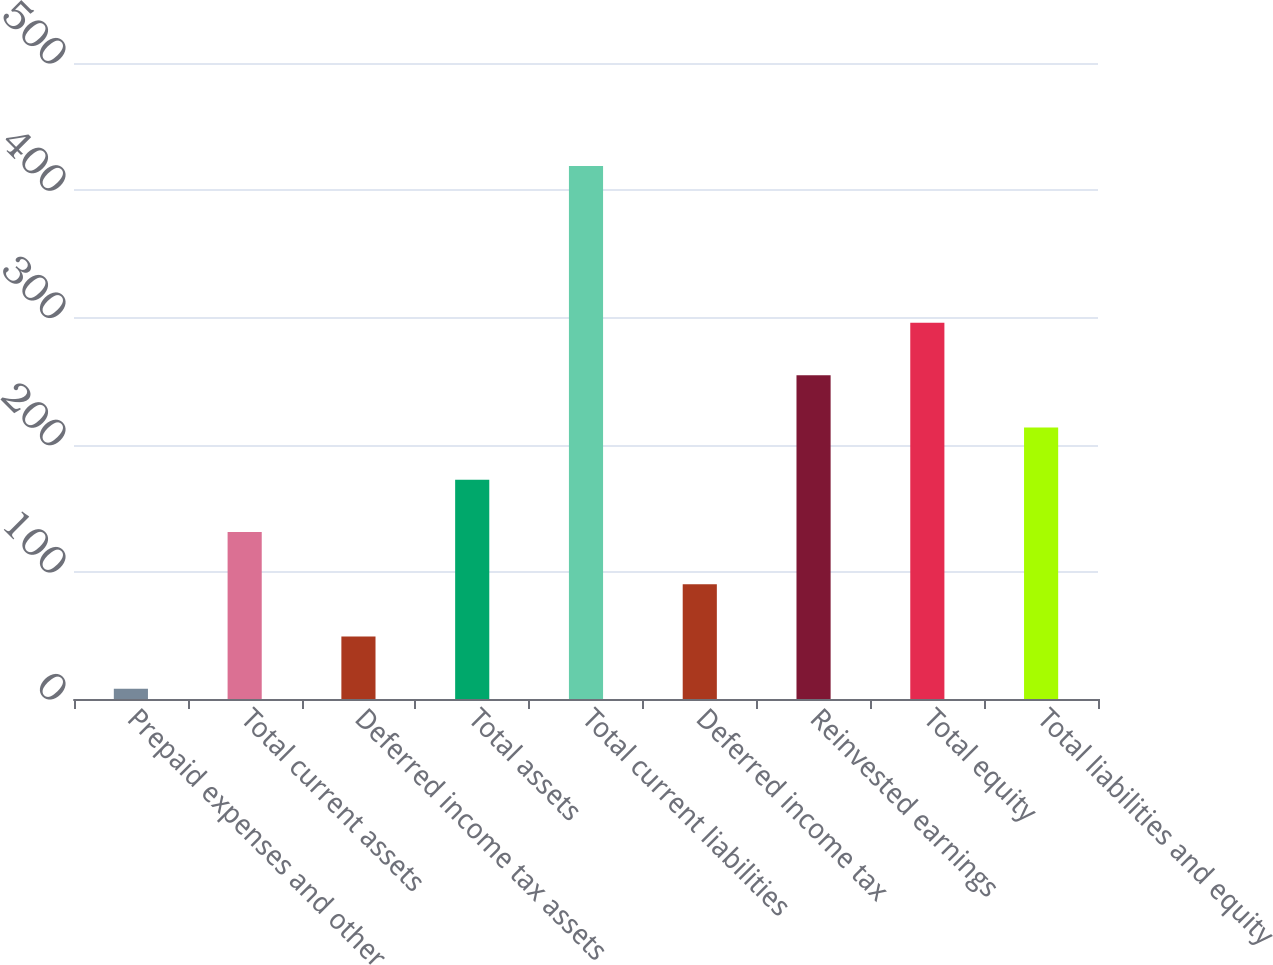<chart> <loc_0><loc_0><loc_500><loc_500><bar_chart><fcel>Prepaid expenses and other<fcel>Total current assets<fcel>Deferred income tax assets<fcel>Total assets<fcel>Total current liabilities<fcel>Deferred income tax<fcel>Reinvested earnings<fcel>Total equity<fcel>Total liabilities and equity<nl><fcel>8<fcel>131.3<fcel>49.1<fcel>172.4<fcel>419<fcel>90.2<fcel>254.6<fcel>295.7<fcel>213.5<nl></chart> 